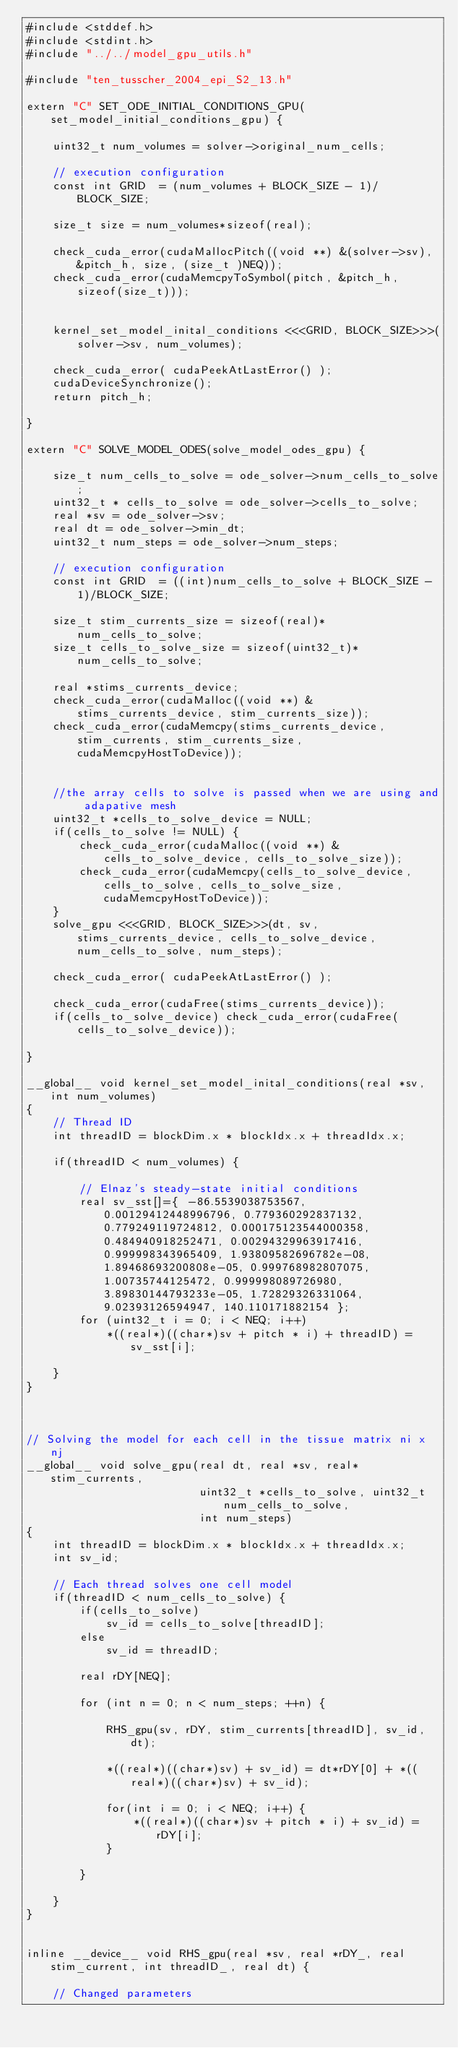Convert code to text. <code><loc_0><loc_0><loc_500><loc_500><_Cuda_>#include <stddef.h>
#include <stdint.h>
#include "../../model_gpu_utils.h"

#include "ten_tusscher_2004_epi_S2_13.h"

extern "C" SET_ODE_INITIAL_CONDITIONS_GPU(set_model_initial_conditions_gpu) {

    uint32_t num_volumes = solver->original_num_cells;

    // execution configuration
    const int GRID  = (num_volumes + BLOCK_SIZE - 1)/BLOCK_SIZE;

    size_t size = num_volumes*sizeof(real);

    check_cuda_error(cudaMallocPitch((void **) &(solver->sv), &pitch_h, size, (size_t )NEQ));
    check_cuda_error(cudaMemcpyToSymbol(pitch, &pitch_h, sizeof(size_t)));


    kernel_set_model_inital_conditions <<<GRID, BLOCK_SIZE>>>(solver->sv, num_volumes);

    check_cuda_error( cudaPeekAtLastError() );
    cudaDeviceSynchronize();
    return pitch_h;

}

extern "C" SOLVE_MODEL_ODES(solve_model_odes_gpu) {

    size_t num_cells_to_solve = ode_solver->num_cells_to_solve;
    uint32_t * cells_to_solve = ode_solver->cells_to_solve;
    real *sv = ode_solver->sv;
    real dt = ode_solver->min_dt;
    uint32_t num_steps = ode_solver->num_steps;

    // execution configuration
    const int GRID  = ((int)num_cells_to_solve + BLOCK_SIZE - 1)/BLOCK_SIZE;

    size_t stim_currents_size = sizeof(real)*num_cells_to_solve;
    size_t cells_to_solve_size = sizeof(uint32_t)*num_cells_to_solve;

    real *stims_currents_device;
    check_cuda_error(cudaMalloc((void **) &stims_currents_device, stim_currents_size));
    check_cuda_error(cudaMemcpy(stims_currents_device, stim_currents, stim_currents_size, cudaMemcpyHostToDevice));


    //the array cells to solve is passed when we are using and adapative mesh
    uint32_t *cells_to_solve_device = NULL;
    if(cells_to_solve != NULL) {
        check_cuda_error(cudaMalloc((void **) &cells_to_solve_device, cells_to_solve_size));
        check_cuda_error(cudaMemcpy(cells_to_solve_device, cells_to_solve, cells_to_solve_size, cudaMemcpyHostToDevice));
    }
    solve_gpu <<<GRID, BLOCK_SIZE>>>(dt, sv, stims_currents_device, cells_to_solve_device, num_cells_to_solve, num_steps);

    check_cuda_error( cudaPeekAtLastError() );

    check_cuda_error(cudaFree(stims_currents_device));
    if(cells_to_solve_device) check_cuda_error(cudaFree(cells_to_solve_device));

}

__global__ void kernel_set_model_inital_conditions(real *sv, int num_volumes)
{
    // Thread ID
    int threadID = blockDim.x * blockIdx.x + threadIdx.x;

    if(threadID < num_volumes) {

        // Elnaz's steady-state initial conditions
        real sv_sst[]={ -86.5539038753567, 0.00129412448996796, 0.779360292837132, 0.779249119724812, 0.000175123544000358, 0.484940918252471, 0.00294329963917416, 0.999998343965409, 1.93809582696782e-08, 1.89468693200808e-05, 0.999768982807075, 1.00735744125472, 0.999998089726980, 3.89830144793233e-05, 1.72829326331064, 9.02393126594947, 140.110171882154 }; 
        for (uint32_t i = 0; i < NEQ; i++)
            *((real*)((char*)sv + pitch * i) + threadID) = sv_sst[i];

    }
}



// Solving the model for each cell in the tissue matrix ni x nj
__global__ void solve_gpu(real dt, real *sv, real* stim_currents,
                          uint32_t *cells_to_solve, uint32_t num_cells_to_solve,
                          int num_steps)
{
    int threadID = blockDim.x * blockIdx.x + threadIdx.x;
    int sv_id;

    // Each thread solves one cell model
    if(threadID < num_cells_to_solve) {
        if(cells_to_solve)
            sv_id = cells_to_solve[threadID];
        else
            sv_id = threadID;

        real rDY[NEQ];

        for (int n = 0; n < num_steps; ++n) {

            RHS_gpu(sv, rDY, stim_currents[threadID], sv_id, dt);

            *((real*)((char*)sv) + sv_id) = dt*rDY[0] + *((real*)((char*)sv) + sv_id);

            for(int i = 0; i < NEQ; i++) {
                *((real*)((char*)sv + pitch * i) + sv_id) = rDY[i];
            }
            
        }

    }
}


inline __device__ void RHS_gpu(real *sv, real *rDY_, real stim_current, int threadID_, real dt) {

    // Changed parameters</code> 